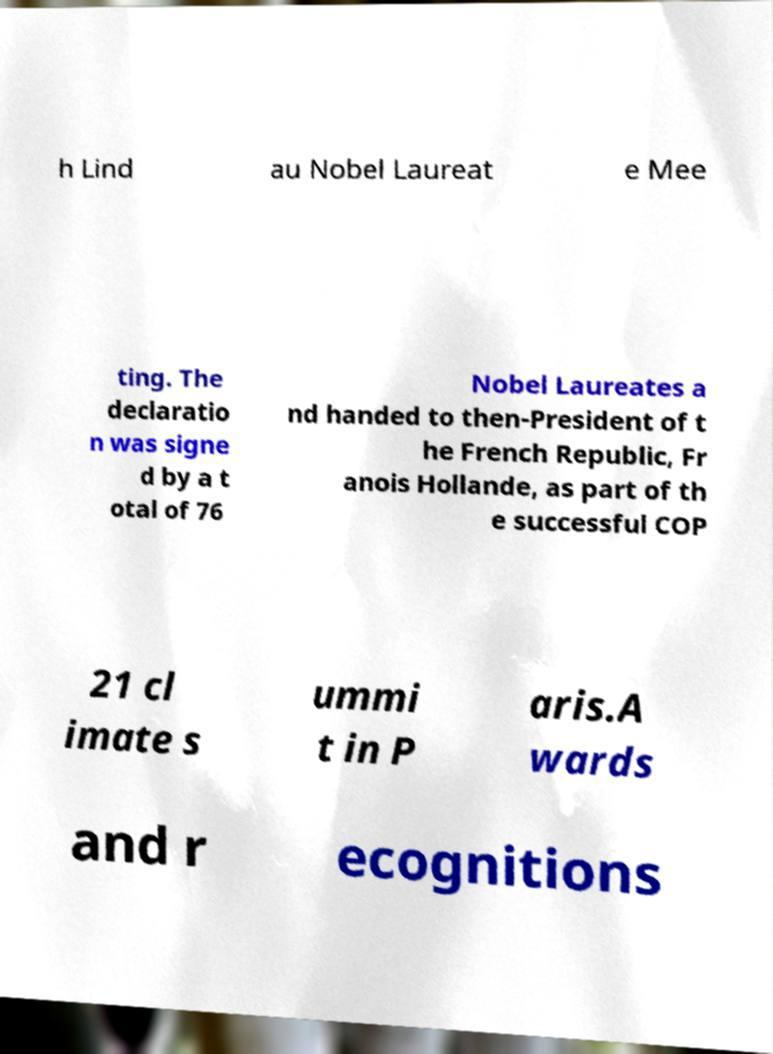Could you extract and type out the text from this image? h Lind au Nobel Laureat e Mee ting. The declaratio n was signe d by a t otal of 76 Nobel Laureates a nd handed to then-President of t he French Republic, Fr anois Hollande, as part of th e successful COP 21 cl imate s ummi t in P aris.A wards and r ecognitions 